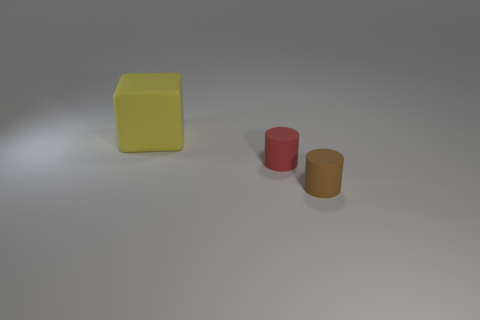Add 1 red things. How many objects exist? 4 Subtract all cylinders. How many objects are left? 1 Subtract all brown rubber things. Subtract all brown rubber objects. How many objects are left? 1 Add 2 brown objects. How many brown objects are left? 3 Add 3 big red metallic spheres. How many big red metallic spheres exist? 3 Subtract 0 green cylinders. How many objects are left? 3 